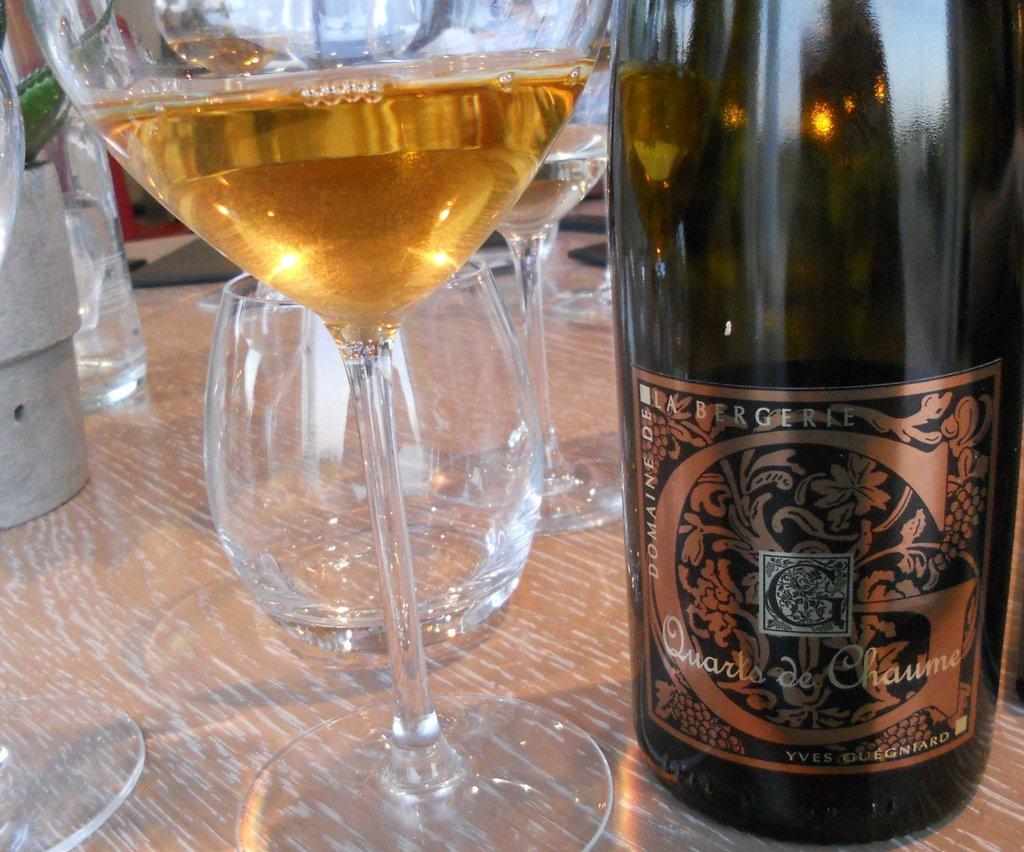<image>
Create a compact narrative representing the image presented. A bottle of Bergerie wine is on a table with several wine glasses. 